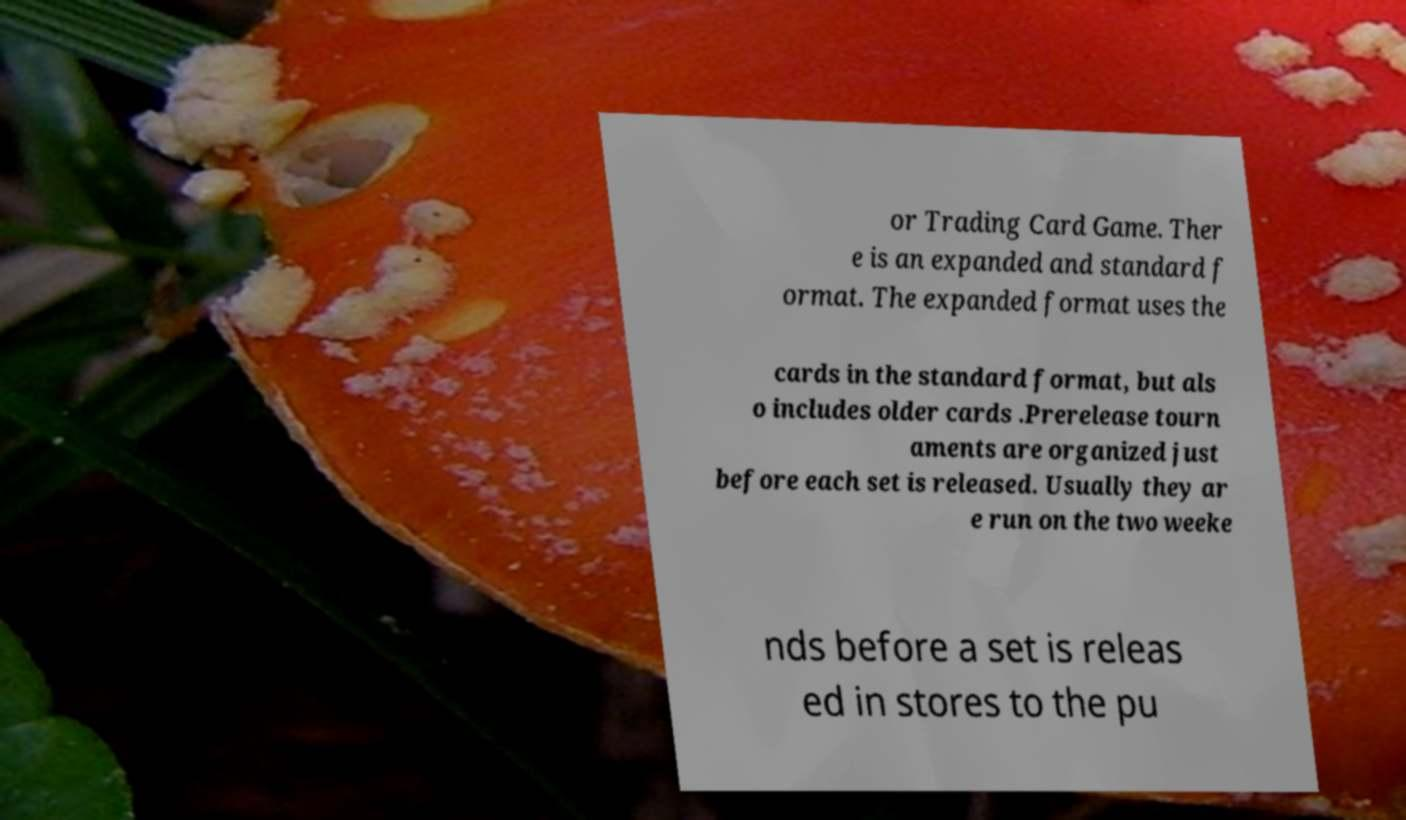Can you accurately transcribe the text from the provided image for me? or Trading Card Game. Ther e is an expanded and standard f ormat. The expanded format uses the cards in the standard format, but als o includes older cards .Prerelease tourn aments are organized just before each set is released. Usually they ar e run on the two weeke nds before a set is releas ed in stores to the pu 